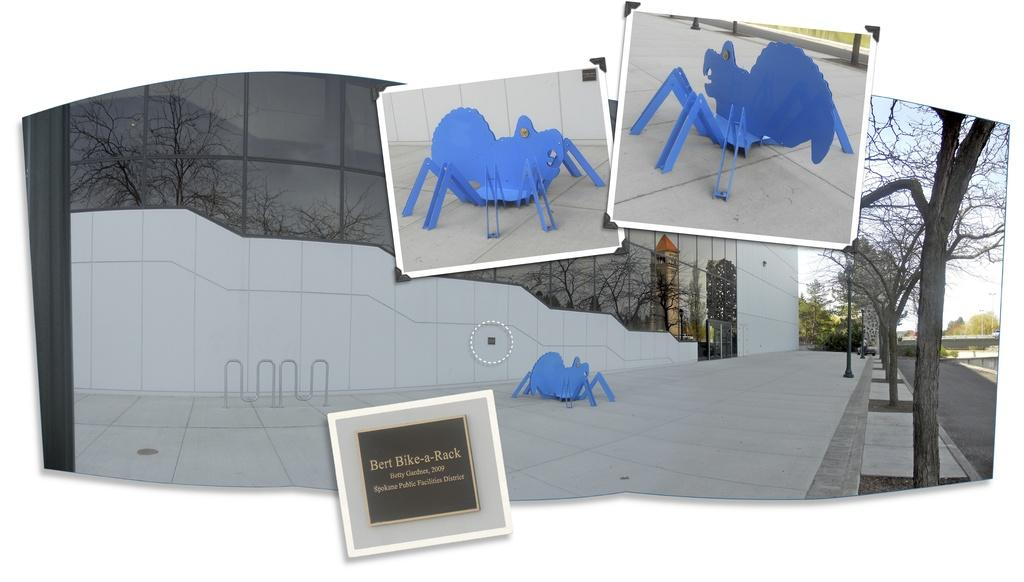<image>
Summarize the visual content of the image. A sculpture by Betty Gardner includes a big blue spider. 